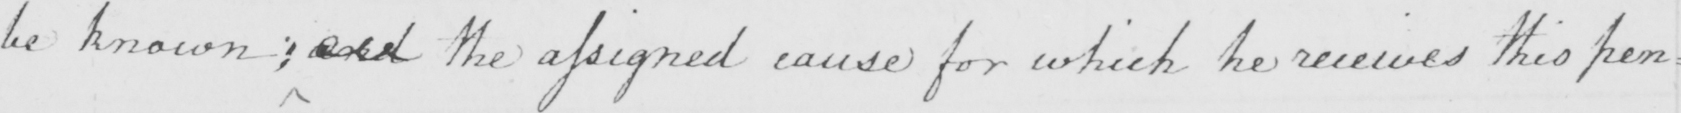What text is written in this handwritten line? be known ; and the assigned cause for which he receives this pen= 